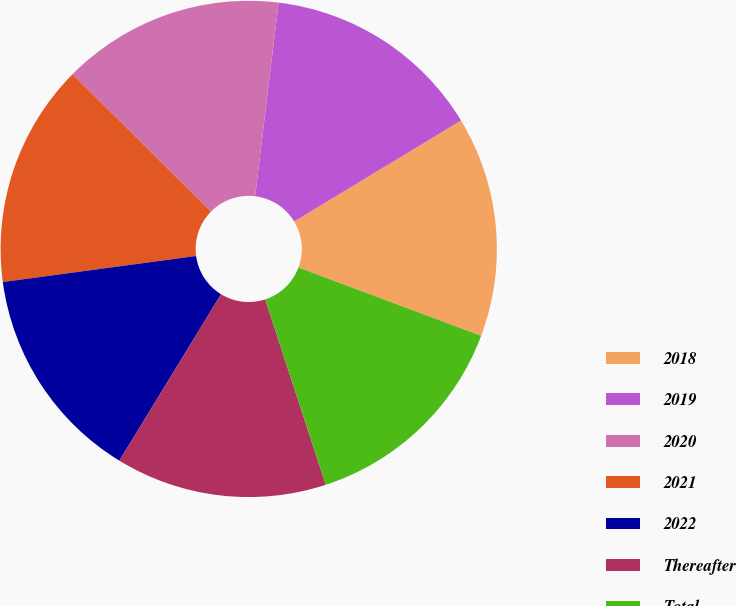Convert chart. <chart><loc_0><loc_0><loc_500><loc_500><pie_chart><fcel>2018<fcel>2019<fcel>2020<fcel>2021<fcel>2022<fcel>Thereafter<fcel>Total<nl><fcel>14.35%<fcel>14.42%<fcel>14.49%<fcel>14.56%<fcel>14.14%<fcel>13.75%<fcel>14.28%<nl></chart> 